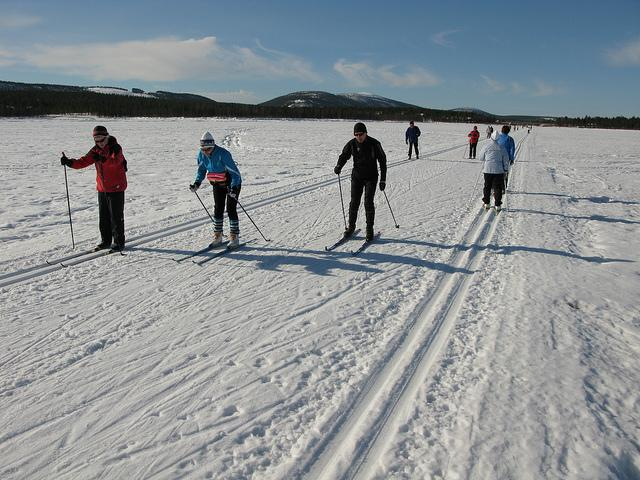What is the location of the sun in the image? Please explain your reasoning. left. Shadows of people cross country skiing fall to the left of them. 